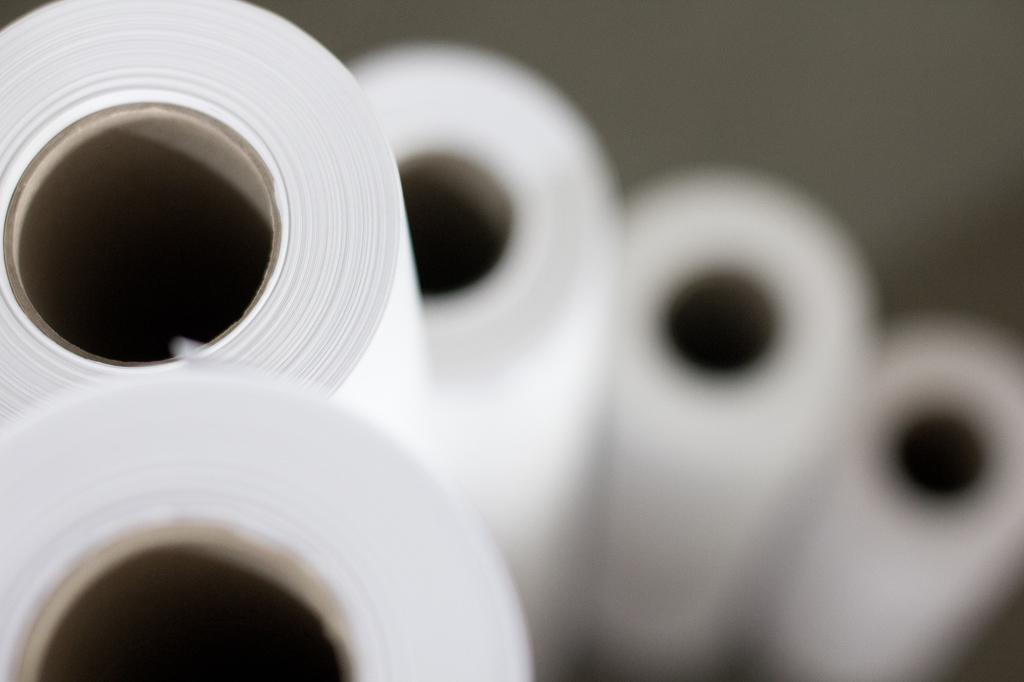What is the color of the bundles in the image? The bundles in the image are white in color. Can you describe the background of the image? The background of the image is blurred. What flavor of ice cream is being served on the hydrant in the image? There is no hydrant or ice cream present in the image. How many times does the tongue appear in the image? There is no tongue present in the image. 